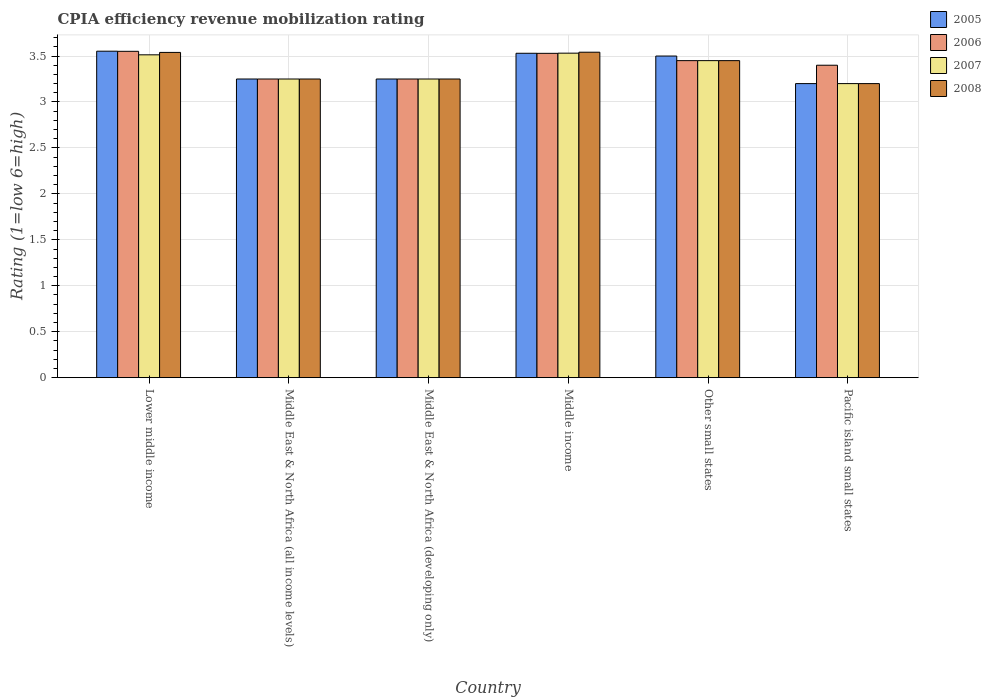How many different coloured bars are there?
Offer a very short reply. 4. Are the number of bars per tick equal to the number of legend labels?
Your answer should be very brief. Yes. Are the number of bars on each tick of the X-axis equal?
Your response must be concise. Yes. How many bars are there on the 1st tick from the left?
Offer a very short reply. 4. What is the label of the 5th group of bars from the left?
Offer a very short reply. Other small states. In how many cases, is the number of bars for a given country not equal to the number of legend labels?
Keep it short and to the point. 0. What is the CPIA rating in 2007 in Other small states?
Provide a short and direct response. 3.45. Across all countries, what is the maximum CPIA rating in 2006?
Offer a very short reply. 3.55. Across all countries, what is the minimum CPIA rating in 2007?
Provide a succinct answer. 3.2. In which country was the CPIA rating in 2007 maximum?
Your answer should be very brief. Middle income. In which country was the CPIA rating in 2007 minimum?
Your response must be concise. Pacific island small states. What is the total CPIA rating in 2005 in the graph?
Provide a short and direct response. 20.28. What is the difference between the CPIA rating in 2008 in Lower middle income and that in Middle East & North Africa (all income levels)?
Provide a short and direct response. 0.29. What is the difference between the CPIA rating in 2007 in Middle East & North Africa (developing only) and the CPIA rating in 2005 in Middle income?
Provide a succinct answer. -0.28. What is the average CPIA rating in 2008 per country?
Provide a succinct answer. 3.37. What is the difference between the CPIA rating of/in 2006 and CPIA rating of/in 2005 in Middle income?
Give a very brief answer. -0. What is the ratio of the CPIA rating in 2008 in Other small states to that in Pacific island small states?
Your response must be concise. 1.08. Is the difference between the CPIA rating in 2006 in Lower middle income and Pacific island small states greater than the difference between the CPIA rating in 2005 in Lower middle income and Pacific island small states?
Provide a short and direct response. No. What is the difference between the highest and the second highest CPIA rating in 2008?
Keep it short and to the point. -0. What is the difference between the highest and the lowest CPIA rating in 2005?
Give a very brief answer. 0.35. In how many countries, is the CPIA rating in 2006 greater than the average CPIA rating in 2006 taken over all countries?
Your answer should be very brief. 3. Is the sum of the CPIA rating in 2006 in Lower middle income and Middle income greater than the maximum CPIA rating in 2008 across all countries?
Offer a very short reply. Yes. How many bars are there?
Make the answer very short. 24. Are all the bars in the graph horizontal?
Your answer should be very brief. No. Are the values on the major ticks of Y-axis written in scientific E-notation?
Ensure brevity in your answer.  No. Where does the legend appear in the graph?
Offer a terse response. Top right. How many legend labels are there?
Offer a very short reply. 4. How are the legend labels stacked?
Your response must be concise. Vertical. What is the title of the graph?
Keep it short and to the point. CPIA efficiency revenue mobilization rating. What is the label or title of the Y-axis?
Your answer should be very brief. Rating (1=low 6=high). What is the Rating (1=low 6=high) in 2005 in Lower middle income?
Give a very brief answer. 3.55. What is the Rating (1=low 6=high) of 2006 in Lower middle income?
Keep it short and to the point. 3.55. What is the Rating (1=low 6=high) of 2007 in Lower middle income?
Provide a short and direct response. 3.51. What is the Rating (1=low 6=high) of 2008 in Lower middle income?
Your answer should be compact. 3.54. What is the Rating (1=low 6=high) of 2007 in Middle East & North Africa (all income levels)?
Ensure brevity in your answer.  3.25. What is the Rating (1=low 6=high) of 2008 in Middle East & North Africa (all income levels)?
Keep it short and to the point. 3.25. What is the Rating (1=low 6=high) in 2006 in Middle East & North Africa (developing only)?
Ensure brevity in your answer.  3.25. What is the Rating (1=low 6=high) in 2007 in Middle East & North Africa (developing only)?
Ensure brevity in your answer.  3.25. What is the Rating (1=low 6=high) in 2005 in Middle income?
Your answer should be very brief. 3.53. What is the Rating (1=low 6=high) of 2006 in Middle income?
Keep it short and to the point. 3.53. What is the Rating (1=low 6=high) in 2007 in Middle income?
Your response must be concise. 3.53. What is the Rating (1=low 6=high) in 2008 in Middle income?
Your response must be concise. 3.54. What is the Rating (1=low 6=high) in 2006 in Other small states?
Keep it short and to the point. 3.45. What is the Rating (1=low 6=high) in 2007 in Other small states?
Make the answer very short. 3.45. What is the Rating (1=low 6=high) of 2008 in Other small states?
Offer a very short reply. 3.45. What is the Rating (1=low 6=high) of 2005 in Pacific island small states?
Your response must be concise. 3.2. Across all countries, what is the maximum Rating (1=low 6=high) of 2005?
Your answer should be very brief. 3.55. Across all countries, what is the maximum Rating (1=low 6=high) of 2006?
Provide a short and direct response. 3.55. Across all countries, what is the maximum Rating (1=low 6=high) in 2007?
Provide a succinct answer. 3.53. Across all countries, what is the maximum Rating (1=low 6=high) of 2008?
Your answer should be very brief. 3.54. Across all countries, what is the minimum Rating (1=low 6=high) in 2005?
Offer a terse response. 3.2. Across all countries, what is the minimum Rating (1=low 6=high) in 2008?
Give a very brief answer. 3.2. What is the total Rating (1=low 6=high) of 2005 in the graph?
Offer a very short reply. 20.28. What is the total Rating (1=low 6=high) of 2006 in the graph?
Ensure brevity in your answer.  20.43. What is the total Rating (1=low 6=high) of 2007 in the graph?
Offer a terse response. 20.19. What is the total Rating (1=low 6=high) of 2008 in the graph?
Offer a very short reply. 20.23. What is the difference between the Rating (1=low 6=high) of 2005 in Lower middle income and that in Middle East & North Africa (all income levels)?
Ensure brevity in your answer.  0.3. What is the difference between the Rating (1=low 6=high) in 2006 in Lower middle income and that in Middle East & North Africa (all income levels)?
Ensure brevity in your answer.  0.3. What is the difference between the Rating (1=low 6=high) in 2007 in Lower middle income and that in Middle East & North Africa (all income levels)?
Make the answer very short. 0.26. What is the difference between the Rating (1=low 6=high) in 2008 in Lower middle income and that in Middle East & North Africa (all income levels)?
Offer a very short reply. 0.29. What is the difference between the Rating (1=low 6=high) in 2005 in Lower middle income and that in Middle East & North Africa (developing only)?
Provide a succinct answer. 0.3. What is the difference between the Rating (1=low 6=high) of 2006 in Lower middle income and that in Middle East & North Africa (developing only)?
Offer a terse response. 0.3. What is the difference between the Rating (1=low 6=high) of 2007 in Lower middle income and that in Middle East & North Africa (developing only)?
Ensure brevity in your answer.  0.26. What is the difference between the Rating (1=low 6=high) of 2008 in Lower middle income and that in Middle East & North Africa (developing only)?
Keep it short and to the point. 0.29. What is the difference between the Rating (1=low 6=high) of 2005 in Lower middle income and that in Middle income?
Provide a short and direct response. 0.02. What is the difference between the Rating (1=low 6=high) in 2006 in Lower middle income and that in Middle income?
Your answer should be compact. 0.02. What is the difference between the Rating (1=low 6=high) in 2007 in Lower middle income and that in Middle income?
Offer a terse response. -0.02. What is the difference between the Rating (1=low 6=high) in 2008 in Lower middle income and that in Middle income?
Make the answer very short. -0. What is the difference between the Rating (1=low 6=high) of 2005 in Lower middle income and that in Other small states?
Give a very brief answer. 0.05. What is the difference between the Rating (1=low 6=high) in 2006 in Lower middle income and that in Other small states?
Offer a very short reply. 0.1. What is the difference between the Rating (1=low 6=high) of 2007 in Lower middle income and that in Other small states?
Provide a short and direct response. 0.06. What is the difference between the Rating (1=low 6=high) in 2008 in Lower middle income and that in Other small states?
Your answer should be very brief. 0.09. What is the difference between the Rating (1=low 6=high) of 2005 in Lower middle income and that in Pacific island small states?
Provide a succinct answer. 0.35. What is the difference between the Rating (1=low 6=high) in 2006 in Lower middle income and that in Pacific island small states?
Your response must be concise. 0.15. What is the difference between the Rating (1=low 6=high) in 2007 in Lower middle income and that in Pacific island small states?
Offer a very short reply. 0.31. What is the difference between the Rating (1=low 6=high) in 2008 in Lower middle income and that in Pacific island small states?
Provide a short and direct response. 0.34. What is the difference between the Rating (1=low 6=high) of 2005 in Middle East & North Africa (all income levels) and that in Middle East & North Africa (developing only)?
Your answer should be compact. 0. What is the difference between the Rating (1=low 6=high) of 2006 in Middle East & North Africa (all income levels) and that in Middle East & North Africa (developing only)?
Make the answer very short. 0. What is the difference between the Rating (1=low 6=high) of 2007 in Middle East & North Africa (all income levels) and that in Middle East & North Africa (developing only)?
Your response must be concise. 0. What is the difference between the Rating (1=low 6=high) of 2005 in Middle East & North Africa (all income levels) and that in Middle income?
Make the answer very short. -0.28. What is the difference between the Rating (1=low 6=high) of 2006 in Middle East & North Africa (all income levels) and that in Middle income?
Offer a very short reply. -0.28. What is the difference between the Rating (1=low 6=high) in 2007 in Middle East & North Africa (all income levels) and that in Middle income?
Ensure brevity in your answer.  -0.28. What is the difference between the Rating (1=low 6=high) of 2008 in Middle East & North Africa (all income levels) and that in Middle income?
Offer a terse response. -0.29. What is the difference between the Rating (1=low 6=high) of 2006 in Middle East & North Africa (all income levels) and that in Pacific island small states?
Your answer should be compact. -0.15. What is the difference between the Rating (1=low 6=high) of 2008 in Middle East & North Africa (all income levels) and that in Pacific island small states?
Your answer should be compact. 0.05. What is the difference between the Rating (1=low 6=high) of 2005 in Middle East & North Africa (developing only) and that in Middle income?
Give a very brief answer. -0.28. What is the difference between the Rating (1=low 6=high) of 2006 in Middle East & North Africa (developing only) and that in Middle income?
Provide a short and direct response. -0.28. What is the difference between the Rating (1=low 6=high) of 2007 in Middle East & North Africa (developing only) and that in Middle income?
Give a very brief answer. -0.28. What is the difference between the Rating (1=low 6=high) in 2008 in Middle East & North Africa (developing only) and that in Middle income?
Your response must be concise. -0.29. What is the difference between the Rating (1=low 6=high) in 2006 in Middle East & North Africa (developing only) and that in Other small states?
Provide a short and direct response. -0.2. What is the difference between the Rating (1=low 6=high) of 2005 in Middle East & North Africa (developing only) and that in Pacific island small states?
Provide a short and direct response. 0.05. What is the difference between the Rating (1=low 6=high) of 2005 in Middle income and that in Other small states?
Your response must be concise. 0.03. What is the difference between the Rating (1=low 6=high) of 2006 in Middle income and that in Other small states?
Your response must be concise. 0.08. What is the difference between the Rating (1=low 6=high) of 2007 in Middle income and that in Other small states?
Ensure brevity in your answer.  0.08. What is the difference between the Rating (1=low 6=high) of 2008 in Middle income and that in Other small states?
Provide a succinct answer. 0.09. What is the difference between the Rating (1=low 6=high) in 2005 in Middle income and that in Pacific island small states?
Provide a short and direct response. 0.33. What is the difference between the Rating (1=low 6=high) of 2006 in Middle income and that in Pacific island small states?
Give a very brief answer. 0.13. What is the difference between the Rating (1=low 6=high) in 2007 in Middle income and that in Pacific island small states?
Your answer should be compact. 0.33. What is the difference between the Rating (1=low 6=high) in 2008 in Middle income and that in Pacific island small states?
Provide a short and direct response. 0.34. What is the difference between the Rating (1=low 6=high) in 2005 in Other small states and that in Pacific island small states?
Keep it short and to the point. 0.3. What is the difference between the Rating (1=low 6=high) in 2006 in Other small states and that in Pacific island small states?
Offer a very short reply. 0.05. What is the difference between the Rating (1=low 6=high) of 2005 in Lower middle income and the Rating (1=low 6=high) of 2006 in Middle East & North Africa (all income levels)?
Provide a succinct answer. 0.3. What is the difference between the Rating (1=low 6=high) in 2005 in Lower middle income and the Rating (1=low 6=high) in 2007 in Middle East & North Africa (all income levels)?
Provide a succinct answer. 0.3. What is the difference between the Rating (1=low 6=high) of 2005 in Lower middle income and the Rating (1=low 6=high) of 2008 in Middle East & North Africa (all income levels)?
Provide a succinct answer. 0.3. What is the difference between the Rating (1=low 6=high) in 2006 in Lower middle income and the Rating (1=low 6=high) in 2007 in Middle East & North Africa (all income levels)?
Ensure brevity in your answer.  0.3. What is the difference between the Rating (1=low 6=high) of 2006 in Lower middle income and the Rating (1=low 6=high) of 2008 in Middle East & North Africa (all income levels)?
Your answer should be very brief. 0.3. What is the difference between the Rating (1=low 6=high) in 2007 in Lower middle income and the Rating (1=low 6=high) in 2008 in Middle East & North Africa (all income levels)?
Make the answer very short. 0.26. What is the difference between the Rating (1=low 6=high) of 2005 in Lower middle income and the Rating (1=low 6=high) of 2006 in Middle East & North Africa (developing only)?
Provide a succinct answer. 0.3. What is the difference between the Rating (1=low 6=high) of 2005 in Lower middle income and the Rating (1=low 6=high) of 2007 in Middle East & North Africa (developing only)?
Your answer should be very brief. 0.3. What is the difference between the Rating (1=low 6=high) of 2005 in Lower middle income and the Rating (1=low 6=high) of 2008 in Middle East & North Africa (developing only)?
Offer a terse response. 0.3. What is the difference between the Rating (1=low 6=high) in 2006 in Lower middle income and the Rating (1=low 6=high) in 2007 in Middle East & North Africa (developing only)?
Offer a terse response. 0.3. What is the difference between the Rating (1=low 6=high) in 2006 in Lower middle income and the Rating (1=low 6=high) in 2008 in Middle East & North Africa (developing only)?
Keep it short and to the point. 0.3. What is the difference between the Rating (1=low 6=high) of 2007 in Lower middle income and the Rating (1=low 6=high) of 2008 in Middle East & North Africa (developing only)?
Give a very brief answer. 0.26. What is the difference between the Rating (1=low 6=high) in 2005 in Lower middle income and the Rating (1=low 6=high) in 2006 in Middle income?
Offer a terse response. 0.02. What is the difference between the Rating (1=low 6=high) in 2005 in Lower middle income and the Rating (1=low 6=high) in 2007 in Middle income?
Offer a very short reply. 0.02. What is the difference between the Rating (1=low 6=high) in 2005 in Lower middle income and the Rating (1=low 6=high) in 2008 in Middle income?
Ensure brevity in your answer.  0.01. What is the difference between the Rating (1=low 6=high) in 2006 in Lower middle income and the Rating (1=low 6=high) in 2007 in Middle income?
Provide a short and direct response. 0.02. What is the difference between the Rating (1=low 6=high) of 2006 in Lower middle income and the Rating (1=low 6=high) of 2008 in Middle income?
Give a very brief answer. 0.01. What is the difference between the Rating (1=low 6=high) in 2007 in Lower middle income and the Rating (1=low 6=high) in 2008 in Middle income?
Your answer should be compact. -0.03. What is the difference between the Rating (1=low 6=high) in 2005 in Lower middle income and the Rating (1=low 6=high) in 2006 in Other small states?
Keep it short and to the point. 0.1. What is the difference between the Rating (1=low 6=high) in 2005 in Lower middle income and the Rating (1=low 6=high) in 2007 in Other small states?
Make the answer very short. 0.1. What is the difference between the Rating (1=low 6=high) of 2005 in Lower middle income and the Rating (1=low 6=high) of 2008 in Other small states?
Provide a short and direct response. 0.1. What is the difference between the Rating (1=low 6=high) in 2006 in Lower middle income and the Rating (1=low 6=high) in 2007 in Other small states?
Offer a very short reply. 0.1. What is the difference between the Rating (1=low 6=high) of 2006 in Lower middle income and the Rating (1=low 6=high) of 2008 in Other small states?
Give a very brief answer. 0.1. What is the difference between the Rating (1=low 6=high) of 2007 in Lower middle income and the Rating (1=low 6=high) of 2008 in Other small states?
Offer a terse response. 0.06. What is the difference between the Rating (1=low 6=high) of 2005 in Lower middle income and the Rating (1=low 6=high) of 2006 in Pacific island small states?
Keep it short and to the point. 0.15. What is the difference between the Rating (1=low 6=high) of 2005 in Lower middle income and the Rating (1=low 6=high) of 2007 in Pacific island small states?
Ensure brevity in your answer.  0.35. What is the difference between the Rating (1=low 6=high) in 2005 in Lower middle income and the Rating (1=low 6=high) in 2008 in Pacific island small states?
Offer a terse response. 0.35. What is the difference between the Rating (1=low 6=high) of 2006 in Lower middle income and the Rating (1=low 6=high) of 2007 in Pacific island small states?
Your response must be concise. 0.35. What is the difference between the Rating (1=low 6=high) in 2006 in Lower middle income and the Rating (1=low 6=high) in 2008 in Pacific island small states?
Keep it short and to the point. 0.35. What is the difference between the Rating (1=low 6=high) of 2007 in Lower middle income and the Rating (1=low 6=high) of 2008 in Pacific island small states?
Your answer should be very brief. 0.31. What is the difference between the Rating (1=low 6=high) in 2005 in Middle East & North Africa (all income levels) and the Rating (1=low 6=high) in 2006 in Middle income?
Provide a succinct answer. -0.28. What is the difference between the Rating (1=low 6=high) in 2005 in Middle East & North Africa (all income levels) and the Rating (1=low 6=high) in 2007 in Middle income?
Offer a terse response. -0.28. What is the difference between the Rating (1=low 6=high) in 2005 in Middle East & North Africa (all income levels) and the Rating (1=low 6=high) in 2008 in Middle income?
Your answer should be compact. -0.29. What is the difference between the Rating (1=low 6=high) of 2006 in Middle East & North Africa (all income levels) and the Rating (1=low 6=high) of 2007 in Middle income?
Provide a succinct answer. -0.28. What is the difference between the Rating (1=low 6=high) in 2006 in Middle East & North Africa (all income levels) and the Rating (1=low 6=high) in 2008 in Middle income?
Your response must be concise. -0.29. What is the difference between the Rating (1=low 6=high) in 2007 in Middle East & North Africa (all income levels) and the Rating (1=low 6=high) in 2008 in Middle income?
Provide a succinct answer. -0.29. What is the difference between the Rating (1=low 6=high) of 2005 in Middle East & North Africa (all income levels) and the Rating (1=low 6=high) of 2006 in Other small states?
Keep it short and to the point. -0.2. What is the difference between the Rating (1=low 6=high) of 2005 in Middle East & North Africa (all income levels) and the Rating (1=low 6=high) of 2008 in Other small states?
Your answer should be compact. -0.2. What is the difference between the Rating (1=low 6=high) in 2006 in Middle East & North Africa (all income levels) and the Rating (1=low 6=high) in 2007 in Other small states?
Ensure brevity in your answer.  -0.2. What is the difference between the Rating (1=low 6=high) of 2006 in Middle East & North Africa (all income levels) and the Rating (1=low 6=high) of 2008 in Other small states?
Provide a short and direct response. -0.2. What is the difference between the Rating (1=low 6=high) of 2005 in Middle East & North Africa (all income levels) and the Rating (1=low 6=high) of 2008 in Pacific island small states?
Ensure brevity in your answer.  0.05. What is the difference between the Rating (1=low 6=high) of 2006 in Middle East & North Africa (all income levels) and the Rating (1=low 6=high) of 2007 in Pacific island small states?
Offer a very short reply. 0.05. What is the difference between the Rating (1=low 6=high) in 2006 in Middle East & North Africa (all income levels) and the Rating (1=low 6=high) in 2008 in Pacific island small states?
Ensure brevity in your answer.  0.05. What is the difference between the Rating (1=low 6=high) of 2007 in Middle East & North Africa (all income levels) and the Rating (1=low 6=high) of 2008 in Pacific island small states?
Keep it short and to the point. 0.05. What is the difference between the Rating (1=low 6=high) of 2005 in Middle East & North Africa (developing only) and the Rating (1=low 6=high) of 2006 in Middle income?
Offer a terse response. -0.28. What is the difference between the Rating (1=low 6=high) in 2005 in Middle East & North Africa (developing only) and the Rating (1=low 6=high) in 2007 in Middle income?
Your answer should be compact. -0.28. What is the difference between the Rating (1=low 6=high) of 2005 in Middle East & North Africa (developing only) and the Rating (1=low 6=high) of 2008 in Middle income?
Provide a short and direct response. -0.29. What is the difference between the Rating (1=low 6=high) in 2006 in Middle East & North Africa (developing only) and the Rating (1=low 6=high) in 2007 in Middle income?
Offer a terse response. -0.28. What is the difference between the Rating (1=low 6=high) in 2006 in Middle East & North Africa (developing only) and the Rating (1=low 6=high) in 2008 in Middle income?
Offer a terse response. -0.29. What is the difference between the Rating (1=low 6=high) of 2007 in Middle East & North Africa (developing only) and the Rating (1=low 6=high) of 2008 in Middle income?
Make the answer very short. -0.29. What is the difference between the Rating (1=low 6=high) of 2005 in Middle East & North Africa (developing only) and the Rating (1=low 6=high) of 2006 in Other small states?
Provide a short and direct response. -0.2. What is the difference between the Rating (1=low 6=high) of 2006 in Middle East & North Africa (developing only) and the Rating (1=low 6=high) of 2007 in Other small states?
Make the answer very short. -0.2. What is the difference between the Rating (1=low 6=high) of 2007 in Middle East & North Africa (developing only) and the Rating (1=low 6=high) of 2008 in Other small states?
Provide a succinct answer. -0.2. What is the difference between the Rating (1=low 6=high) in 2005 in Middle East & North Africa (developing only) and the Rating (1=low 6=high) in 2008 in Pacific island small states?
Give a very brief answer. 0.05. What is the difference between the Rating (1=low 6=high) of 2006 in Middle East & North Africa (developing only) and the Rating (1=low 6=high) of 2007 in Pacific island small states?
Make the answer very short. 0.05. What is the difference between the Rating (1=low 6=high) of 2006 in Middle East & North Africa (developing only) and the Rating (1=low 6=high) of 2008 in Pacific island small states?
Keep it short and to the point. 0.05. What is the difference between the Rating (1=low 6=high) in 2005 in Middle income and the Rating (1=low 6=high) in 2006 in Other small states?
Offer a very short reply. 0.08. What is the difference between the Rating (1=low 6=high) in 2005 in Middle income and the Rating (1=low 6=high) in 2008 in Other small states?
Make the answer very short. 0.08. What is the difference between the Rating (1=low 6=high) of 2006 in Middle income and the Rating (1=low 6=high) of 2007 in Other small states?
Your answer should be compact. 0.08. What is the difference between the Rating (1=low 6=high) of 2006 in Middle income and the Rating (1=low 6=high) of 2008 in Other small states?
Provide a short and direct response. 0.08. What is the difference between the Rating (1=low 6=high) of 2007 in Middle income and the Rating (1=low 6=high) of 2008 in Other small states?
Your answer should be compact. 0.08. What is the difference between the Rating (1=low 6=high) of 2005 in Middle income and the Rating (1=low 6=high) of 2006 in Pacific island small states?
Your response must be concise. 0.13. What is the difference between the Rating (1=low 6=high) in 2005 in Middle income and the Rating (1=low 6=high) in 2007 in Pacific island small states?
Your answer should be compact. 0.33. What is the difference between the Rating (1=low 6=high) in 2005 in Middle income and the Rating (1=low 6=high) in 2008 in Pacific island small states?
Your response must be concise. 0.33. What is the difference between the Rating (1=low 6=high) in 2006 in Middle income and the Rating (1=low 6=high) in 2007 in Pacific island small states?
Give a very brief answer. 0.33. What is the difference between the Rating (1=low 6=high) of 2006 in Middle income and the Rating (1=low 6=high) of 2008 in Pacific island small states?
Make the answer very short. 0.33. What is the difference between the Rating (1=low 6=high) in 2007 in Middle income and the Rating (1=low 6=high) in 2008 in Pacific island small states?
Your answer should be very brief. 0.33. What is the difference between the Rating (1=low 6=high) of 2005 in Other small states and the Rating (1=low 6=high) of 2006 in Pacific island small states?
Offer a terse response. 0.1. What is the difference between the Rating (1=low 6=high) in 2005 in Other small states and the Rating (1=low 6=high) in 2007 in Pacific island small states?
Your answer should be compact. 0.3. What is the difference between the Rating (1=low 6=high) in 2005 in Other small states and the Rating (1=low 6=high) in 2008 in Pacific island small states?
Offer a terse response. 0.3. What is the difference between the Rating (1=low 6=high) of 2006 in Other small states and the Rating (1=low 6=high) of 2008 in Pacific island small states?
Give a very brief answer. 0.25. What is the average Rating (1=low 6=high) in 2005 per country?
Your response must be concise. 3.38. What is the average Rating (1=low 6=high) in 2006 per country?
Your answer should be very brief. 3.41. What is the average Rating (1=low 6=high) in 2007 per country?
Provide a succinct answer. 3.37. What is the average Rating (1=low 6=high) of 2008 per country?
Provide a succinct answer. 3.37. What is the difference between the Rating (1=low 6=high) in 2005 and Rating (1=low 6=high) in 2006 in Lower middle income?
Your answer should be compact. 0. What is the difference between the Rating (1=low 6=high) of 2005 and Rating (1=low 6=high) of 2007 in Lower middle income?
Provide a short and direct response. 0.04. What is the difference between the Rating (1=low 6=high) in 2005 and Rating (1=low 6=high) in 2008 in Lower middle income?
Keep it short and to the point. 0.01. What is the difference between the Rating (1=low 6=high) of 2006 and Rating (1=low 6=high) of 2007 in Lower middle income?
Make the answer very short. 0.04. What is the difference between the Rating (1=low 6=high) of 2006 and Rating (1=low 6=high) of 2008 in Lower middle income?
Provide a short and direct response. 0.01. What is the difference between the Rating (1=low 6=high) of 2007 and Rating (1=low 6=high) of 2008 in Lower middle income?
Offer a terse response. -0.03. What is the difference between the Rating (1=low 6=high) in 2005 and Rating (1=low 6=high) in 2007 in Middle East & North Africa (all income levels)?
Your response must be concise. 0. What is the difference between the Rating (1=low 6=high) of 2005 and Rating (1=low 6=high) of 2008 in Middle East & North Africa (all income levels)?
Offer a terse response. 0. What is the difference between the Rating (1=low 6=high) of 2006 and Rating (1=low 6=high) of 2007 in Middle East & North Africa (all income levels)?
Provide a short and direct response. 0. What is the difference between the Rating (1=low 6=high) of 2006 and Rating (1=low 6=high) of 2008 in Middle East & North Africa (all income levels)?
Provide a short and direct response. 0. What is the difference between the Rating (1=low 6=high) in 2005 and Rating (1=low 6=high) in 2006 in Middle East & North Africa (developing only)?
Provide a short and direct response. 0. What is the difference between the Rating (1=low 6=high) of 2005 and Rating (1=low 6=high) of 2007 in Middle East & North Africa (developing only)?
Your answer should be compact. 0. What is the difference between the Rating (1=low 6=high) of 2006 and Rating (1=low 6=high) of 2008 in Middle East & North Africa (developing only)?
Keep it short and to the point. 0. What is the difference between the Rating (1=low 6=high) in 2007 and Rating (1=low 6=high) in 2008 in Middle East & North Africa (developing only)?
Your answer should be very brief. 0. What is the difference between the Rating (1=low 6=high) of 2005 and Rating (1=low 6=high) of 2006 in Middle income?
Your response must be concise. 0. What is the difference between the Rating (1=low 6=high) in 2005 and Rating (1=low 6=high) in 2007 in Middle income?
Your answer should be compact. -0. What is the difference between the Rating (1=low 6=high) of 2005 and Rating (1=low 6=high) of 2008 in Middle income?
Provide a succinct answer. -0.01. What is the difference between the Rating (1=low 6=high) in 2006 and Rating (1=low 6=high) in 2007 in Middle income?
Your answer should be very brief. -0. What is the difference between the Rating (1=low 6=high) in 2006 and Rating (1=low 6=high) in 2008 in Middle income?
Ensure brevity in your answer.  -0.01. What is the difference between the Rating (1=low 6=high) in 2007 and Rating (1=low 6=high) in 2008 in Middle income?
Your response must be concise. -0.01. What is the difference between the Rating (1=low 6=high) in 2005 and Rating (1=low 6=high) in 2006 in Other small states?
Give a very brief answer. 0.05. What is the difference between the Rating (1=low 6=high) in 2006 and Rating (1=low 6=high) in 2008 in Other small states?
Your answer should be compact. 0. What is the difference between the Rating (1=low 6=high) in 2005 and Rating (1=low 6=high) in 2007 in Pacific island small states?
Your answer should be compact. 0. What is the difference between the Rating (1=low 6=high) in 2005 and Rating (1=low 6=high) in 2008 in Pacific island small states?
Make the answer very short. 0. What is the difference between the Rating (1=low 6=high) of 2006 and Rating (1=low 6=high) of 2007 in Pacific island small states?
Give a very brief answer. 0.2. What is the difference between the Rating (1=low 6=high) of 2006 and Rating (1=low 6=high) of 2008 in Pacific island small states?
Your answer should be compact. 0.2. What is the difference between the Rating (1=low 6=high) of 2007 and Rating (1=low 6=high) of 2008 in Pacific island small states?
Provide a succinct answer. 0. What is the ratio of the Rating (1=low 6=high) in 2005 in Lower middle income to that in Middle East & North Africa (all income levels)?
Your response must be concise. 1.09. What is the ratio of the Rating (1=low 6=high) in 2006 in Lower middle income to that in Middle East & North Africa (all income levels)?
Give a very brief answer. 1.09. What is the ratio of the Rating (1=low 6=high) of 2007 in Lower middle income to that in Middle East & North Africa (all income levels)?
Offer a very short reply. 1.08. What is the ratio of the Rating (1=low 6=high) in 2008 in Lower middle income to that in Middle East & North Africa (all income levels)?
Your response must be concise. 1.09. What is the ratio of the Rating (1=low 6=high) of 2005 in Lower middle income to that in Middle East & North Africa (developing only)?
Your response must be concise. 1.09. What is the ratio of the Rating (1=low 6=high) in 2006 in Lower middle income to that in Middle East & North Africa (developing only)?
Provide a succinct answer. 1.09. What is the ratio of the Rating (1=low 6=high) of 2007 in Lower middle income to that in Middle East & North Africa (developing only)?
Give a very brief answer. 1.08. What is the ratio of the Rating (1=low 6=high) in 2008 in Lower middle income to that in Middle East & North Africa (developing only)?
Provide a succinct answer. 1.09. What is the ratio of the Rating (1=low 6=high) of 2005 in Lower middle income to that in Middle income?
Give a very brief answer. 1.01. What is the ratio of the Rating (1=low 6=high) of 2007 in Lower middle income to that in Middle income?
Your response must be concise. 0.99. What is the ratio of the Rating (1=low 6=high) of 2008 in Lower middle income to that in Middle income?
Keep it short and to the point. 1. What is the ratio of the Rating (1=low 6=high) of 2005 in Lower middle income to that in Other small states?
Offer a very short reply. 1.01. What is the ratio of the Rating (1=low 6=high) of 2006 in Lower middle income to that in Other small states?
Ensure brevity in your answer.  1.03. What is the ratio of the Rating (1=low 6=high) in 2007 in Lower middle income to that in Other small states?
Your answer should be compact. 1.02. What is the ratio of the Rating (1=low 6=high) of 2008 in Lower middle income to that in Other small states?
Provide a short and direct response. 1.03. What is the ratio of the Rating (1=low 6=high) in 2005 in Lower middle income to that in Pacific island small states?
Your answer should be very brief. 1.11. What is the ratio of the Rating (1=low 6=high) in 2006 in Lower middle income to that in Pacific island small states?
Your answer should be compact. 1.04. What is the ratio of the Rating (1=low 6=high) in 2007 in Lower middle income to that in Pacific island small states?
Keep it short and to the point. 1.1. What is the ratio of the Rating (1=low 6=high) in 2008 in Lower middle income to that in Pacific island small states?
Ensure brevity in your answer.  1.11. What is the ratio of the Rating (1=low 6=high) of 2005 in Middle East & North Africa (all income levels) to that in Middle East & North Africa (developing only)?
Ensure brevity in your answer.  1. What is the ratio of the Rating (1=low 6=high) of 2006 in Middle East & North Africa (all income levels) to that in Middle East & North Africa (developing only)?
Make the answer very short. 1. What is the ratio of the Rating (1=low 6=high) in 2007 in Middle East & North Africa (all income levels) to that in Middle East & North Africa (developing only)?
Your answer should be very brief. 1. What is the ratio of the Rating (1=low 6=high) of 2008 in Middle East & North Africa (all income levels) to that in Middle East & North Africa (developing only)?
Your answer should be compact. 1. What is the ratio of the Rating (1=low 6=high) in 2005 in Middle East & North Africa (all income levels) to that in Middle income?
Provide a short and direct response. 0.92. What is the ratio of the Rating (1=low 6=high) in 2006 in Middle East & North Africa (all income levels) to that in Middle income?
Provide a short and direct response. 0.92. What is the ratio of the Rating (1=low 6=high) in 2007 in Middle East & North Africa (all income levels) to that in Middle income?
Offer a very short reply. 0.92. What is the ratio of the Rating (1=low 6=high) in 2008 in Middle East & North Africa (all income levels) to that in Middle income?
Ensure brevity in your answer.  0.92. What is the ratio of the Rating (1=low 6=high) in 2005 in Middle East & North Africa (all income levels) to that in Other small states?
Your answer should be compact. 0.93. What is the ratio of the Rating (1=low 6=high) in 2006 in Middle East & North Africa (all income levels) to that in Other small states?
Offer a terse response. 0.94. What is the ratio of the Rating (1=low 6=high) of 2007 in Middle East & North Africa (all income levels) to that in Other small states?
Provide a short and direct response. 0.94. What is the ratio of the Rating (1=low 6=high) in 2008 in Middle East & North Africa (all income levels) to that in Other small states?
Your answer should be compact. 0.94. What is the ratio of the Rating (1=low 6=high) of 2005 in Middle East & North Africa (all income levels) to that in Pacific island small states?
Your answer should be compact. 1.02. What is the ratio of the Rating (1=low 6=high) of 2006 in Middle East & North Africa (all income levels) to that in Pacific island small states?
Give a very brief answer. 0.96. What is the ratio of the Rating (1=low 6=high) of 2007 in Middle East & North Africa (all income levels) to that in Pacific island small states?
Offer a terse response. 1.02. What is the ratio of the Rating (1=low 6=high) in 2008 in Middle East & North Africa (all income levels) to that in Pacific island small states?
Provide a succinct answer. 1.02. What is the ratio of the Rating (1=low 6=high) of 2005 in Middle East & North Africa (developing only) to that in Middle income?
Your response must be concise. 0.92. What is the ratio of the Rating (1=low 6=high) in 2006 in Middle East & North Africa (developing only) to that in Middle income?
Provide a succinct answer. 0.92. What is the ratio of the Rating (1=low 6=high) in 2007 in Middle East & North Africa (developing only) to that in Middle income?
Provide a succinct answer. 0.92. What is the ratio of the Rating (1=low 6=high) of 2008 in Middle East & North Africa (developing only) to that in Middle income?
Offer a very short reply. 0.92. What is the ratio of the Rating (1=low 6=high) in 2005 in Middle East & North Africa (developing only) to that in Other small states?
Provide a succinct answer. 0.93. What is the ratio of the Rating (1=low 6=high) in 2006 in Middle East & North Africa (developing only) to that in Other small states?
Provide a short and direct response. 0.94. What is the ratio of the Rating (1=low 6=high) in 2007 in Middle East & North Africa (developing only) to that in Other small states?
Keep it short and to the point. 0.94. What is the ratio of the Rating (1=low 6=high) of 2008 in Middle East & North Africa (developing only) to that in Other small states?
Make the answer very short. 0.94. What is the ratio of the Rating (1=low 6=high) of 2005 in Middle East & North Africa (developing only) to that in Pacific island small states?
Your answer should be compact. 1.02. What is the ratio of the Rating (1=low 6=high) in 2006 in Middle East & North Africa (developing only) to that in Pacific island small states?
Keep it short and to the point. 0.96. What is the ratio of the Rating (1=low 6=high) in 2007 in Middle East & North Africa (developing only) to that in Pacific island small states?
Your answer should be very brief. 1.02. What is the ratio of the Rating (1=low 6=high) of 2008 in Middle East & North Africa (developing only) to that in Pacific island small states?
Provide a short and direct response. 1.02. What is the ratio of the Rating (1=low 6=high) in 2005 in Middle income to that in Other small states?
Your answer should be very brief. 1.01. What is the ratio of the Rating (1=low 6=high) in 2007 in Middle income to that in Other small states?
Your response must be concise. 1.02. What is the ratio of the Rating (1=low 6=high) in 2008 in Middle income to that in Other small states?
Provide a short and direct response. 1.03. What is the ratio of the Rating (1=low 6=high) in 2005 in Middle income to that in Pacific island small states?
Make the answer very short. 1.1. What is the ratio of the Rating (1=low 6=high) in 2006 in Middle income to that in Pacific island small states?
Provide a succinct answer. 1.04. What is the ratio of the Rating (1=low 6=high) in 2007 in Middle income to that in Pacific island small states?
Provide a short and direct response. 1.1. What is the ratio of the Rating (1=low 6=high) of 2008 in Middle income to that in Pacific island small states?
Offer a very short reply. 1.11. What is the ratio of the Rating (1=low 6=high) in 2005 in Other small states to that in Pacific island small states?
Give a very brief answer. 1.09. What is the ratio of the Rating (1=low 6=high) in 2006 in Other small states to that in Pacific island small states?
Your answer should be compact. 1.01. What is the ratio of the Rating (1=low 6=high) of 2007 in Other small states to that in Pacific island small states?
Offer a very short reply. 1.08. What is the ratio of the Rating (1=low 6=high) of 2008 in Other small states to that in Pacific island small states?
Offer a terse response. 1.08. What is the difference between the highest and the second highest Rating (1=low 6=high) in 2005?
Your response must be concise. 0.02. What is the difference between the highest and the second highest Rating (1=low 6=high) in 2006?
Provide a short and direct response. 0.02. What is the difference between the highest and the second highest Rating (1=low 6=high) of 2007?
Offer a very short reply. 0.02. What is the difference between the highest and the second highest Rating (1=low 6=high) in 2008?
Provide a short and direct response. 0. What is the difference between the highest and the lowest Rating (1=low 6=high) in 2005?
Your answer should be very brief. 0.35. What is the difference between the highest and the lowest Rating (1=low 6=high) of 2006?
Ensure brevity in your answer.  0.3. What is the difference between the highest and the lowest Rating (1=low 6=high) of 2007?
Provide a short and direct response. 0.33. What is the difference between the highest and the lowest Rating (1=low 6=high) in 2008?
Make the answer very short. 0.34. 